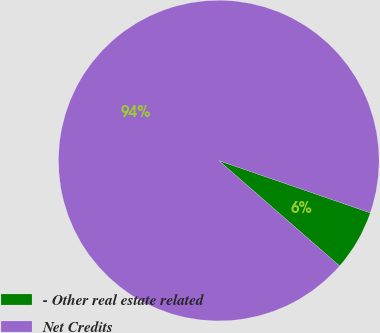<chart> <loc_0><loc_0><loc_500><loc_500><pie_chart><fcel>- Other real estate related<fcel>Net Credits<nl><fcel>6.13%<fcel>93.87%<nl></chart> 